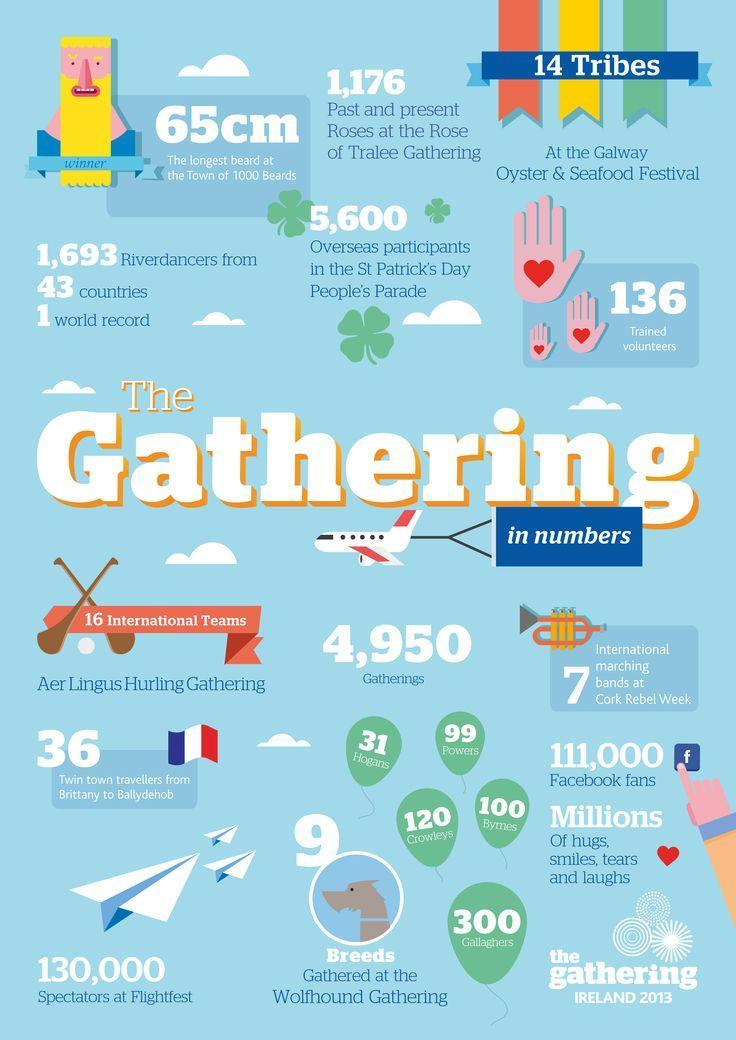How many  variety of dogs had  come for the gathering?
Answer the question with a short phrase. 9 